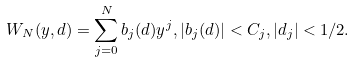Convert formula to latex. <formula><loc_0><loc_0><loc_500><loc_500>W _ { N } ( y , d ) = \sum _ { j = 0 } ^ { N } b _ { j } ( d ) y ^ { j } , | b _ { j } ( d ) | < C _ { j } , | d _ { j } | < 1 / 2 .</formula> 